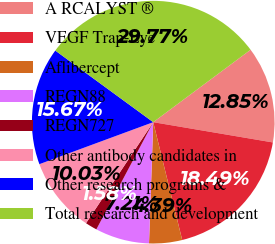Convert chart to OTSL. <chart><loc_0><loc_0><loc_500><loc_500><pie_chart><fcel>A RCALYST ®<fcel>VEGF Trap-Eye<fcel>Aflibercept<fcel>REGN88<fcel>REGN727<fcel>Other antibody candidates in<fcel>Other research programs &<fcel>Total research and development<nl><fcel>12.85%<fcel>18.49%<fcel>4.39%<fcel>7.21%<fcel>1.58%<fcel>10.03%<fcel>15.67%<fcel>29.77%<nl></chart> 